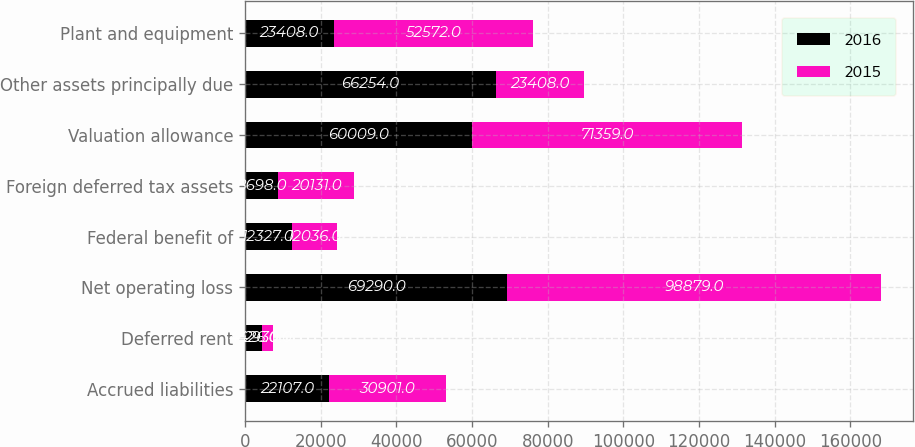Convert chart. <chart><loc_0><loc_0><loc_500><loc_500><stacked_bar_chart><ecel><fcel>Accrued liabilities<fcel>Deferred rent<fcel>Net operating loss<fcel>Federal benefit of<fcel>Foreign deferred tax assets<fcel>Valuation allowance<fcel>Other assets principally due<fcel>Plant and equipment<nl><fcel>2016<fcel>22107<fcel>4426<fcel>69290<fcel>12327<fcel>8698<fcel>60009<fcel>66254<fcel>23408<nl><fcel>2015<fcel>30901<fcel>2930<fcel>98879<fcel>12036<fcel>20131<fcel>71359<fcel>23408<fcel>52572<nl></chart> 